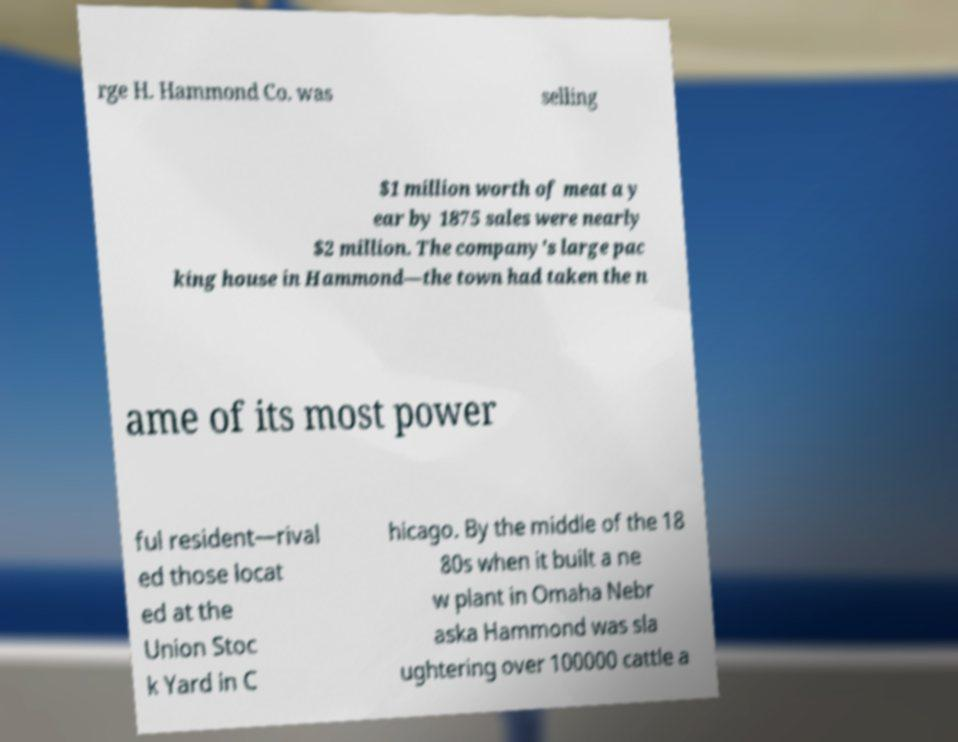Please identify and transcribe the text found in this image. rge H. Hammond Co. was selling $1 million worth of meat a y ear by 1875 sales were nearly $2 million. The company's large pac king house in Hammond—the town had taken the n ame of its most power ful resident—rival ed those locat ed at the Union Stoc k Yard in C hicago. By the middle of the 18 80s when it built a ne w plant in Omaha Nebr aska Hammond was sla ughtering over 100000 cattle a 